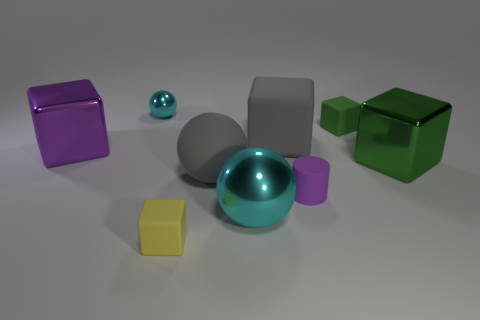Is there anything else that is the same size as the yellow matte block? While it's difficult to determine precise measurements from the image alone, the purple matte cube appears to be of similar size to the yellow matte block when accounting for perspective. 